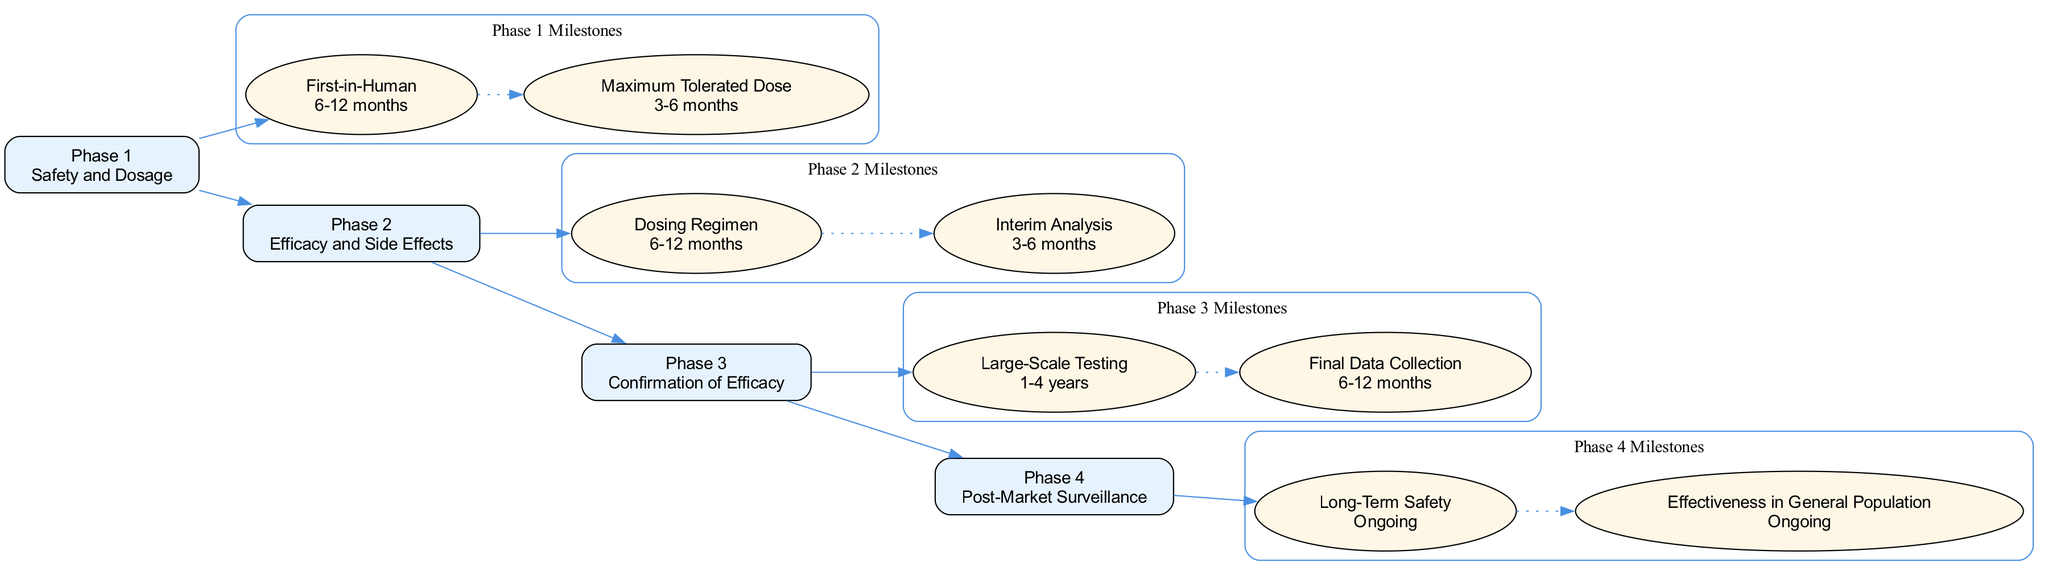What is the description of Phase 1? The diagram lists the description adjacent to the Phase 1 label, which is shown as "Safety and Dosage."
Answer: Safety and Dosage How many key milestones are there in Phase 3? The diagram displays two key milestones for each phase. For Phase 3, it specifically shows "Large-Scale Testing" and "Final Data Collection," amounting to two milestones.
Answer: 2 What is the timeline for the "First-in-Human" milestone? The "First-in-Human" milestone is linked directly under Phase 1 in the diagram, which indicates a timeline of "6-12 months."
Answer: 6-12 months Which phase has the longest timeline for its milestones? By analyzing the timelines listed for each phase, it is evident that Phase 3 has the longest timeline, which is "1-4 years," compared to the other phases.
Answer: Phase 3 What connections are shown between the phases? The diagram illustrates directed edges connecting each phase to the next, indicating a sequential relationship. The edges connect Phase 1 to Phase 2, Phase 2 to Phase 3, and Phase 3 to Phase 4.
Answer: Sequential connections What is the primary focus of Phase 4? The diagram indicates that the focus of Phase 4 is on "Post-Market Surveillance," which is highlighted beneath the Phase 4 label.
Answer: Post-Market Surveillance What type of node is used for the key milestones in the diagram? The diagram specifies that the key milestones are represented as ellipses, which is a unique shape used for this purpose in the visual representation.
Answer: Ellipses What milestone comes first in Phase 2? The diagram shows that "Dosing Regimen" is the first milestone listed under Phase 2, thus indicating its position as the starting point for that phase.
Answer: Dosing Regimen How many phases are represented in the diagram? Upon assessing the diagram, it is clear that there are four distinct phases indicated in the visual structure.
Answer: 4 